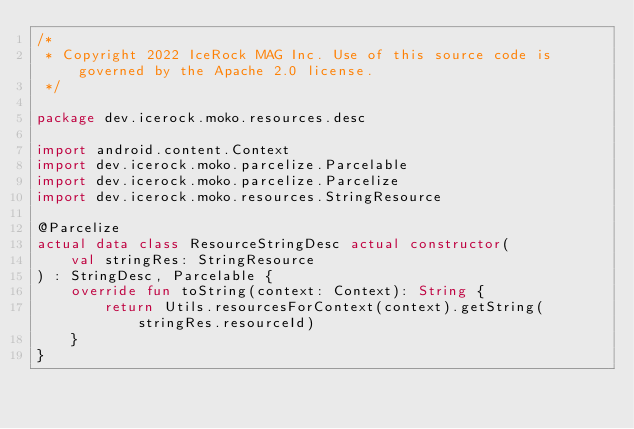Convert code to text. <code><loc_0><loc_0><loc_500><loc_500><_Kotlin_>/*
 * Copyright 2022 IceRock MAG Inc. Use of this source code is governed by the Apache 2.0 license.
 */

package dev.icerock.moko.resources.desc

import android.content.Context
import dev.icerock.moko.parcelize.Parcelable
import dev.icerock.moko.parcelize.Parcelize
import dev.icerock.moko.resources.StringResource

@Parcelize
actual data class ResourceStringDesc actual constructor(
    val stringRes: StringResource
) : StringDesc, Parcelable {
    override fun toString(context: Context): String {
        return Utils.resourcesForContext(context).getString(stringRes.resourceId)
    }
}
</code> 